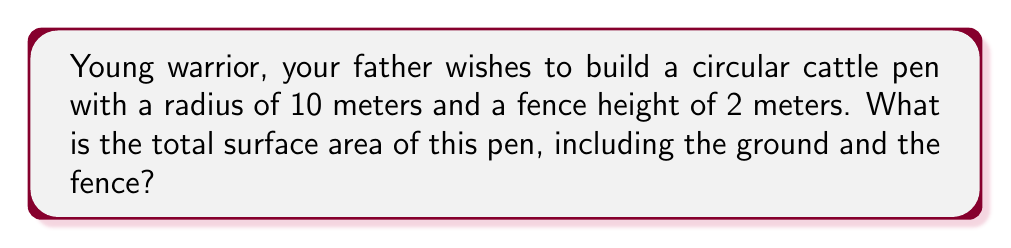Could you help me with this problem? Let's approach this step-by-step:

1) The surface area of the pen consists of two parts:
   a) The circular base (ground)
   b) The cylindrical fence

2) For the circular base:
   - The area of a circle is given by the formula $A = \pi r^2$
   - Here, $r = 10$ meters
   - So, the area of the base is:
     $A_{base} = \pi (10)^2 = 100\pi$ square meters

3) For the cylindrical fence:
   - The area of a cylinder's lateral surface is given by $A = 2\pi rh$
   - Where $r$ is the radius and $h$ is the height
   - Here, $r = 10$ meters and $h = 2$ meters
   - So, the area of the fence is:
     $A_{fence} = 2\pi (10)(2) = 40\pi$ square meters

4) The total surface area is the sum of these two:
   $A_{total} = A_{base} + A_{fence}$
   $A_{total} = 100\pi + 40\pi = 140\pi$ square meters

Therefore, the total surface area of the cattle pen is $140\pi$ square meters.
Answer: $140\pi$ square meters 